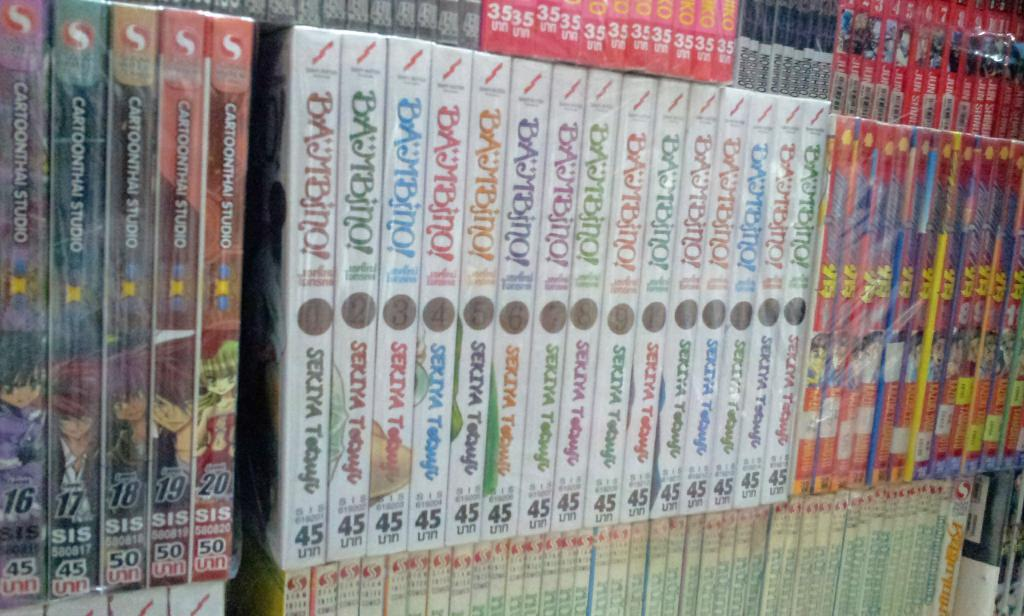<image>
Offer a succinct explanation of the picture presented. A lot of DVD"s with the number 45 are on a shelf stacked next to each other. 